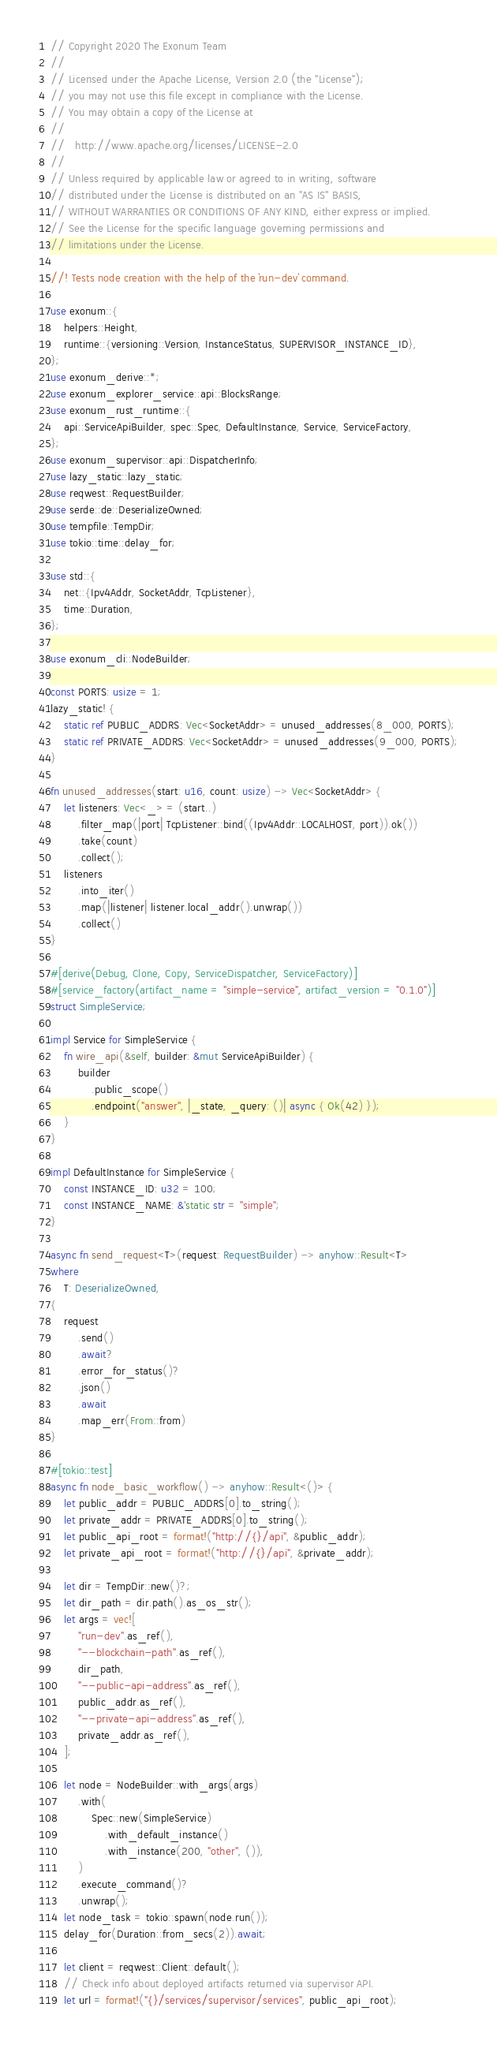Convert code to text. <code><loc_0><loc_0><loc_500><loc_500><_Rust_>// Copyright 2020 The Exonum Team
//
// Licensed under the Apache License, Version 2.0 (the "License");
// you may not use this file except in compliance with the License.
// You may obtain a copy of the License at
//
//   http://www.apache.org/licenses/LICENSE-2.0
//
// Unless required by applicable law or agreed to in writing, software
// distributed under the License is distributed on an "AS IS" BASIS,
// WITHOUT WARRANTIES OR CONDITIONS OF ANY KIND, either express or implied.
// See the License for the specific language governing permissions and
// limitations under the License.

//! Tests node creation with the help of the `run-dev` command.

use exonum::{
    helpers::Height,
    runtime::{versioning::Version, InstanceStatus, SUPERVISOR_INSTANCE_ID},
};
use exonum_derive::*;
use exonum_explorer_service::api::BlocksRange;
use exonum_rust_runtime::{
    api::ServiceApiBuilder, spec::Spec, DefaultInstance, Service, ServiceFactory,
};
use exonum_supervisor::api::DispatcherInfo;
use lazy_static::lazy_static;
use reqwest::RequestBuilder;
use serde::de::DeserializeOwned;
use tempfile::TempDir;
use tokio::time::delay_for;

use std::{
    net::{Ipv4Addr, SocketAddr, TcpListener},
    time::Duration,
};

use exonum_cli::NodeBuilder;

const PORTS: usize = 1;
lazy_static! {
    static ref PUBLIC_ADDRS: Vec<SocketAddr> = unused_addresses(8_000, PORTS);
    static ref PRIVATE_ADDRS: Vec<SocketAddr> = unused_addresses(9_000, PORTS);
}

fn unused_addresses(start: u16, count: usize) -> Vec<SocketAddr> {
    let listeners: Vec<_> = (start..)
        .filter_map(|port| TcpListener::bind((Ipv4Addr::LOCALHOST, port)).ok())
        .take(count)
        .collect();
    listeners
        .into_iter()
        .map(|listener| listener.local_addr().unwrap())
        .collect()
}

#[derive(Debug, Clone, Copy, ServiceDispatcher, ServiceFactory)]
#[service_factory(artifact_name = "simple-service", artifact_version = "0.1.0")]
struct SimpleService;

impl Service for SimpleService {
    fn wire_api(&self, builder: &mut ServiceApiBuilder) {
        builder
            .public_scope()
            .endpoint("answer", |_state, _query: ()| async { Ok(42) });
    }
}

impl DefaultInstance for SimpleService {
    const INSTANCE_ID: u32 = 100;
    const INSTANCE_NAME: &'static str = "simple";
}

async fn send_request<T>(request: RequestBuilder) -> anyhow::Result<T>
where
    T: DeserializeOwned,
{
    request
        .send()
        .await?
        .error_for_status()?
        .json()
        .await
        .map_err(From::from)
}

#[tokio::test]
async fn node_basic_workflow() -> anyhow::Result<()> {
    let public_addr = PUBLIC_ADDRS[0].to_string();
    let private_addr = PRIVATE_ADDRS[0].to_string();
    let public_api_root = format!("http://{}/api", &public_addr);
    let private_api_root = format!("http://{}/api", &private_addr);

    let dir = TempDir::new()?;
    let dir_path = dir.path().as_os_str();
    let args = vec![
        "run-dev".as_ref(),
        "--blockchain-path".as_ref(),
        dir_path,
        "--public-api-address".as_ref(),
        public_addr.as_ref(),
        "--private-api-address".as_ref(),
        private_addr.as_ref(),
    ];

    let node = NodeBuilder::with_args(args)
        .with(
            Spec::new(SimpleService)
                .with_default_instance()
                .with_instance(200, "other", ()),
        )
        .execute_command()?
        .unwrap();
    let node_task = tokio::spawn(node.run());
    delay_for(Duration::from_secs(2)).await;

    let client = reqwest::Client::default();
    // Check info about deployed artifacts returned via supervisor API.
    let url = format!("{}/services/supervisor/services", public_api_root);</code> 